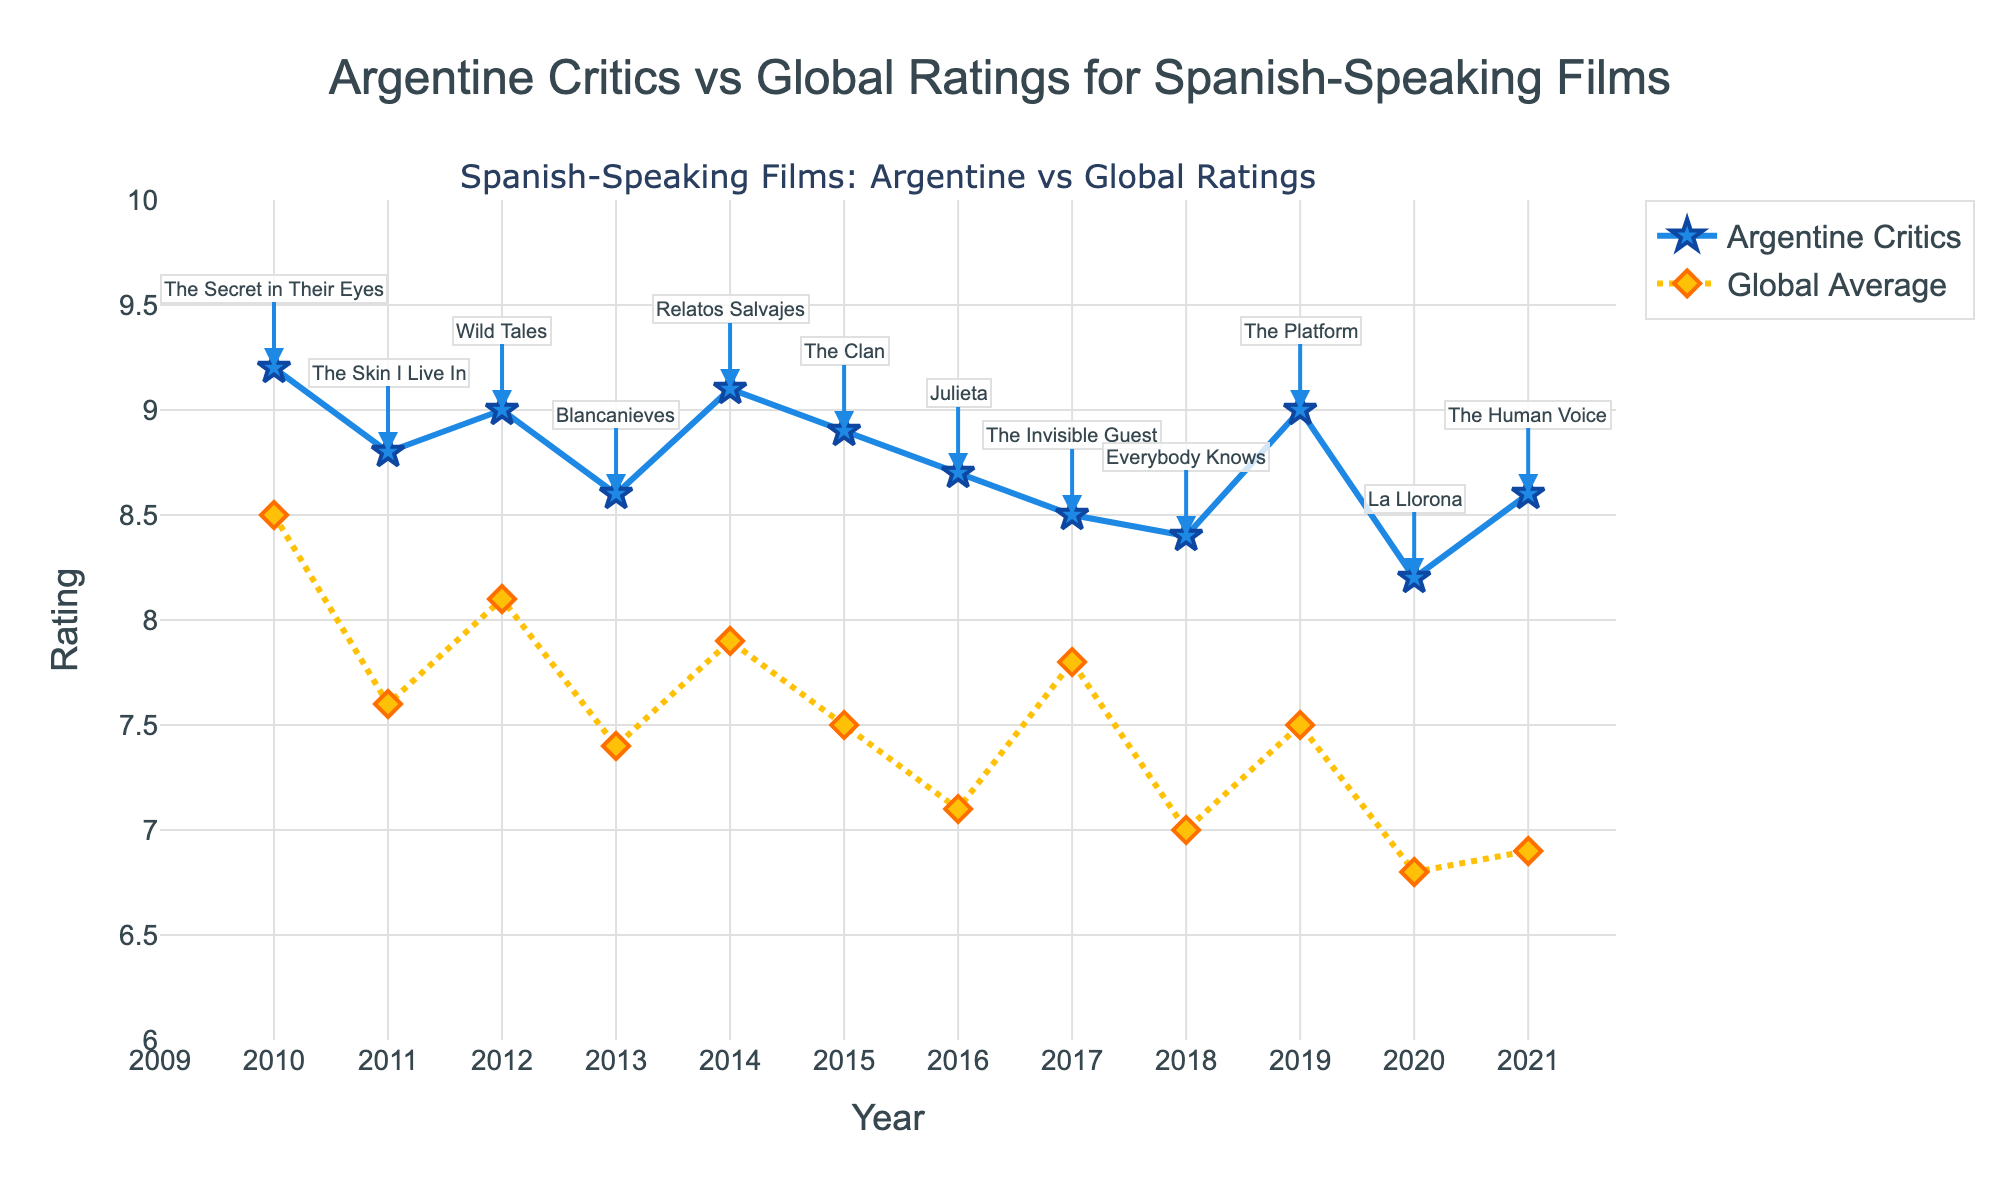What's the title of the graph? The title is usually located at the top center of the graph. In this case, it reads 'Argentine Critics vs Global Ratings for Spanish-Speaking Films'.
Answer: Argentine Critics vs Global Ratings for Spanish-Speaking Films How many years of data are presented in the figure? Each year is typically shown along the x-axis. Count the unique years listed to find the number of years represented. The range is from 2010 to 2021.
Answer: 12 Which film received the highest rating from Argentine critics? By looking at the highest point of the blue line (Argentine Critics), we can see that it corresponds to 'The Secret in Their Eyes' in 2010.
Answer: The Secret in Their Eyes In which year was the largest rating difference between Argentine critics and global averages observed? We find the largest vertical distance between the blue line (Argentine Critics) and the yellow line (Global Average). The year with the most considerable gap would be detected around 2021 for 'The Human Voice'.
Answer: 2021 What is the overall trend in the ratings given by Argentine critics from 2010 to 2021? We need to observe the blue line from left (2010) to right (2021). The overall trend shows relatively high and stable ratings with slight fluctuations.
Answer: Stable with slight fluctuations Which film had a global average rating below 7 in the year it was released? Look at the yellow line (Global Average) and find out where it dips below 7. According to the annotations, 'Julieta' (2016), 'Everybody Knows' (2018), and 'La Llorona' (2020) fall into this category.
Answer: Julieta, Everybody Knows, La Llorona How does the rating for 'Wild Tales' compare between Argentine critics and global audiences? Locate 'Wild Tales' on the graph (2012). The blue marker represents the Argentine Critics rating and the yellow marker represents the Global Average rating. The Argentine Critics rating is higher.
Answer: Argentine Critics: 9.0, Global: 8.1 What is the smallest rating given by Argentine critics? Look for the lowest point on the blue line across all years. This point is in 2020 for 'La Llorona' with a rating of 8.2.
Answer: 8.2 What is the difference between Argentine and global ratings for 'The Platform' in 2019? Find 'The Platform' on the graph (2019) and calculate the difference between the blue value and the yellow value. The difference is 9.0 - 7.5 = 1.5.
Answer: 1.5 